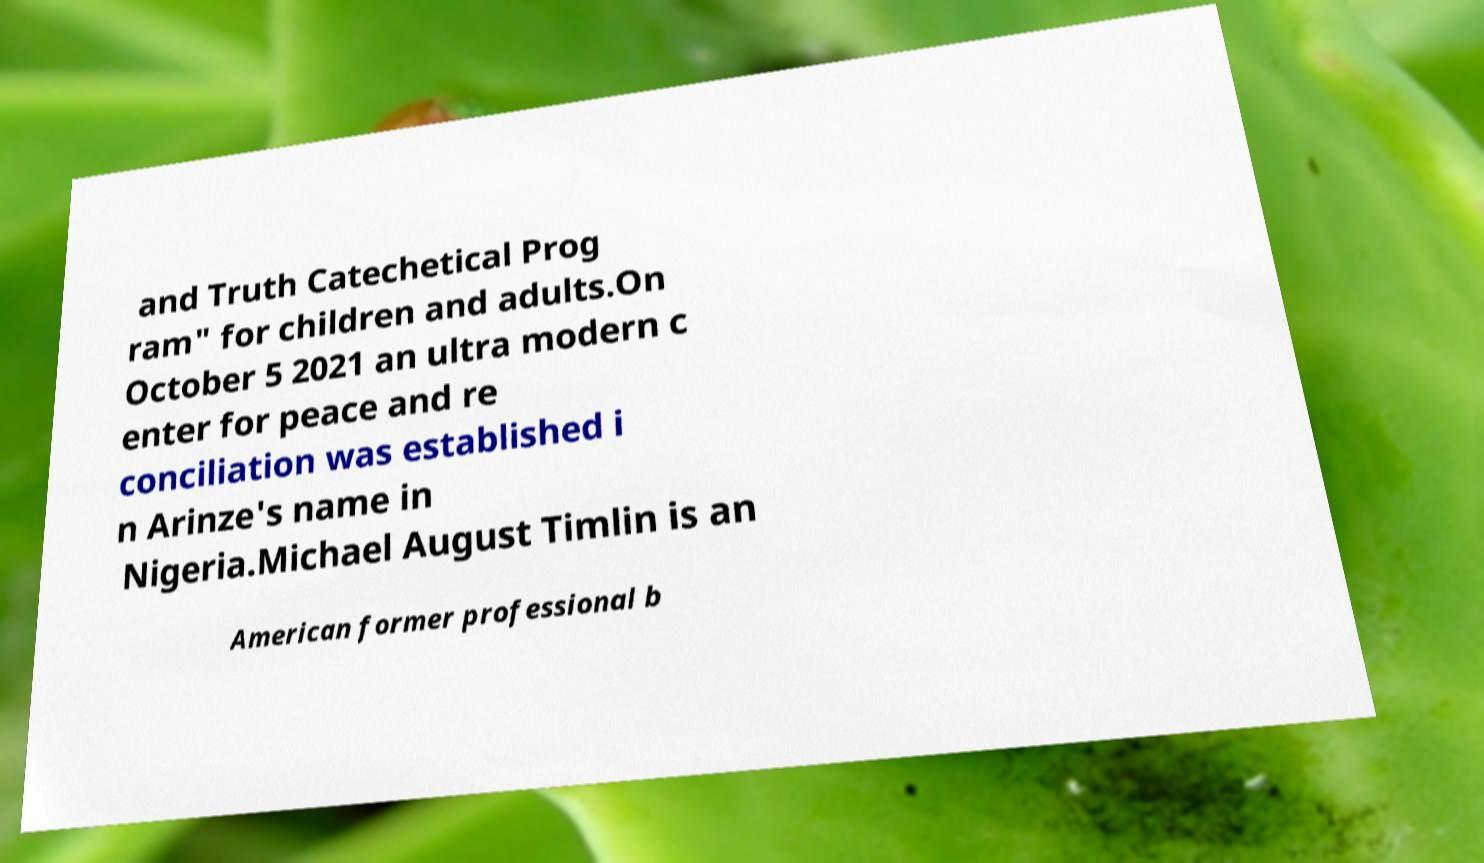Please read and relay the text visible in this image. What does it say? and Truth Catechetical Prog ram" for children and adults.On October 5 2021 an ultra modern c enter for peace and re conciliation was established i n Arinze's name in Nigeria.Michael August Timlin is an American former professional b 